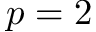<formula> <loc_0><loc_0><loc_500><loc_500>p = 2</formula> 